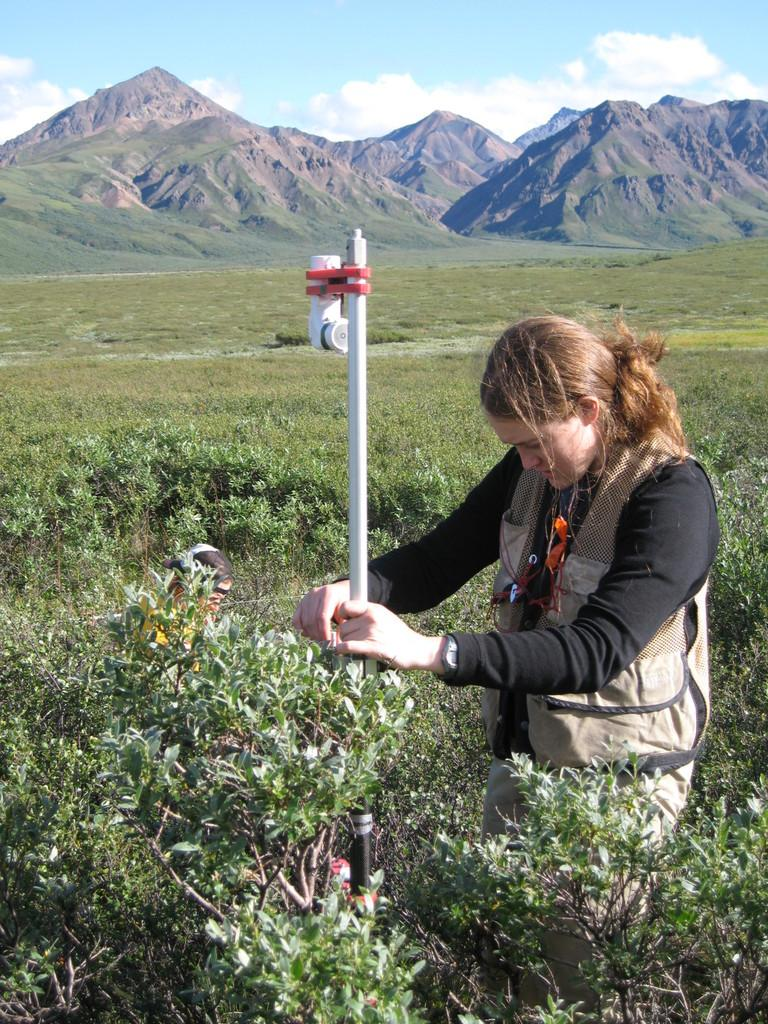What is the main subject of the image? There is a lady standing in the middle of the image. What is the lady holding in the image? The lady is holding a pole. Can you describe the girl's position and surroundings in the image? The girl is sitting beside plants in the image. What can be seen in the distance in the image? There are mountains visible in the background of the image. What type of collar is the lady wearing in the image? There is no collar visible on the lady in the image. What rule is being enforced by the girl sitting beside the plants? There is no indication of any rule being enforced in the image. 